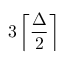<formula> <loc_0><loc_0><loc_500><loc_500>3 \left \lceil { \frac { \Delta } { 2 } } \right \rceil</formula> 